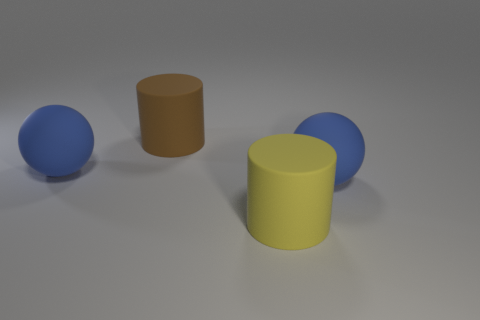Add 3 cylinders. How many objects exist? 7 Subtract all brown cylinders. How many cylinders are left? 1 Subtract 2 balls. How many balls are left? 0 Add 3 large brown cylinders. How many large brown cylinders are left? 4 Add 4 large rubber spheres. How many large rubber spheres exist? 6 Subtract 0 gray spheres. How many objects are left? 4 Subtract all yellow balls. Subtract all purple blocks. How many balls are left? 2 Subtract all gray blocks. How many purple balls are left? 0 Subtract all big green things. Subtract all rubber things. How many objects are left? 0 